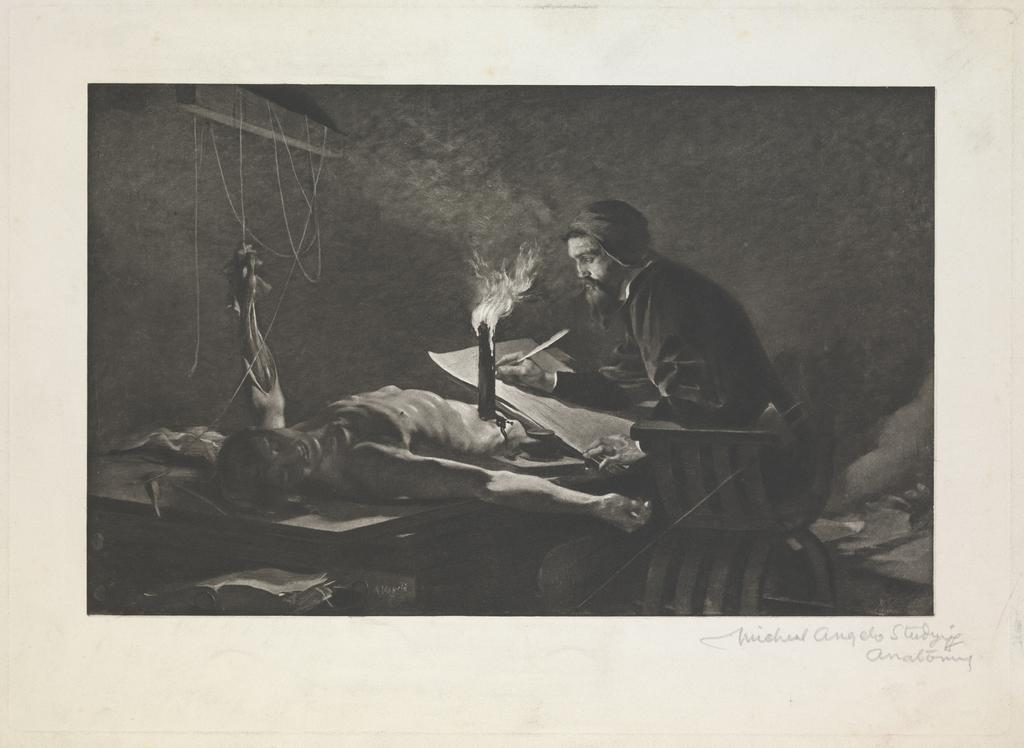What type of characters are present in the image? There are animated people in the image. What else can be seen in the image besides the animated people? There are objects in the image. Where is the text located in the image? The text is at the bottom right side of the image. What type of seed is growing near the gate in the image? There is no seed or gate present in the image. What mark can be seen on the animated people in the image? There is no mention of any marks on the animated people in the image. 